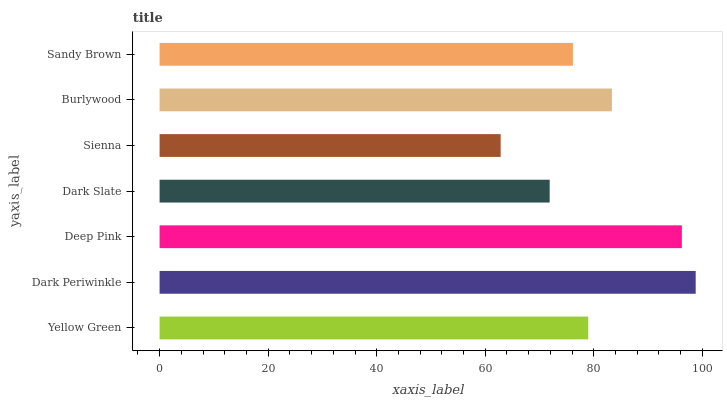Is Sienna the minimum?
Answer yes or no. Yes. Is Dark Periwinkle the maximum?
Answer yes or no. Yes. Is Deep Pink the minimum?
Answer yes or no. No. Is Deep Pink the maximum?
Answer yes or no. No. Is Dark Periwinkle greater than Deep Pink?
Answer yes or no. Yes. Is Deep Pink less than Dark Periwinkle?
Answer yes or no. Yes. Is Deep Pink greater than Dark Periwinkle?
Answer yes or no. No. Is Dark Periwinkle less than Deep Pink?
Answer yes or no. No. Is Yellow Green the high median?
Answer yes or no. Yes. Is Yellow Green the low median?
Answer yes or no. Yes. Is Sandy Brown the high median?
Answer yes or no. No. Is Sienna the low median?
Answer yes or no. No. 